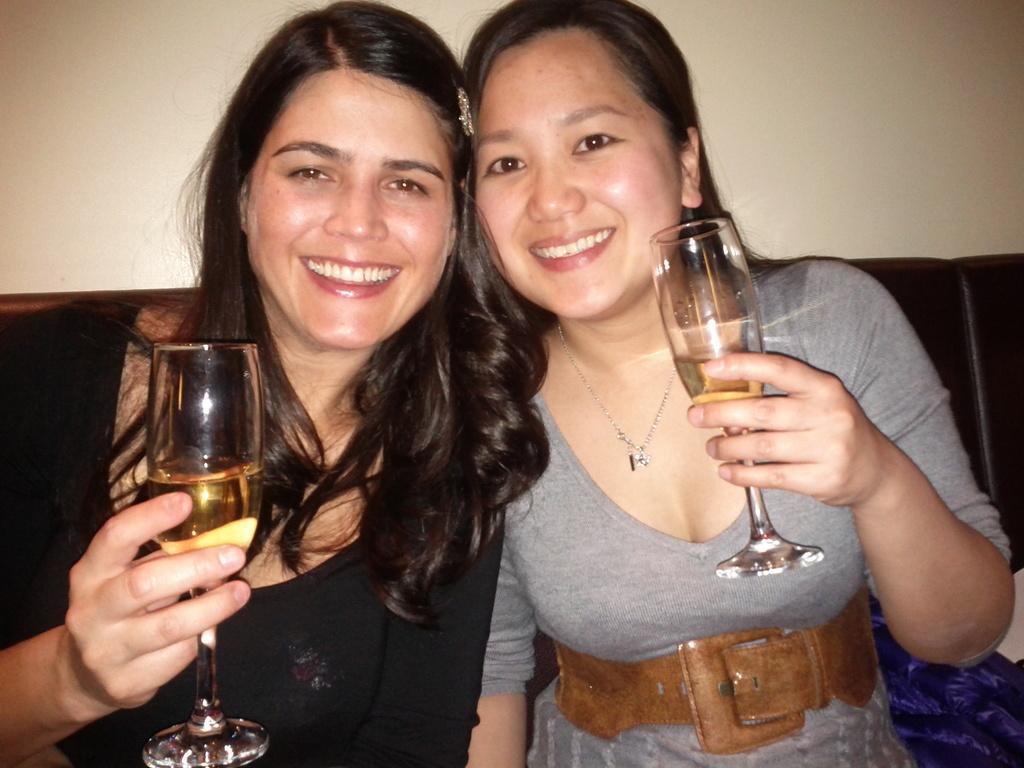How would you summarize this image in a sentence or two? In the image we can see there are women who are sitting in front and they are holding wine glass in their hand which is filled with wine and they both are smiling. They are sitting on sofa, at the back there is wall which is of white colour. 